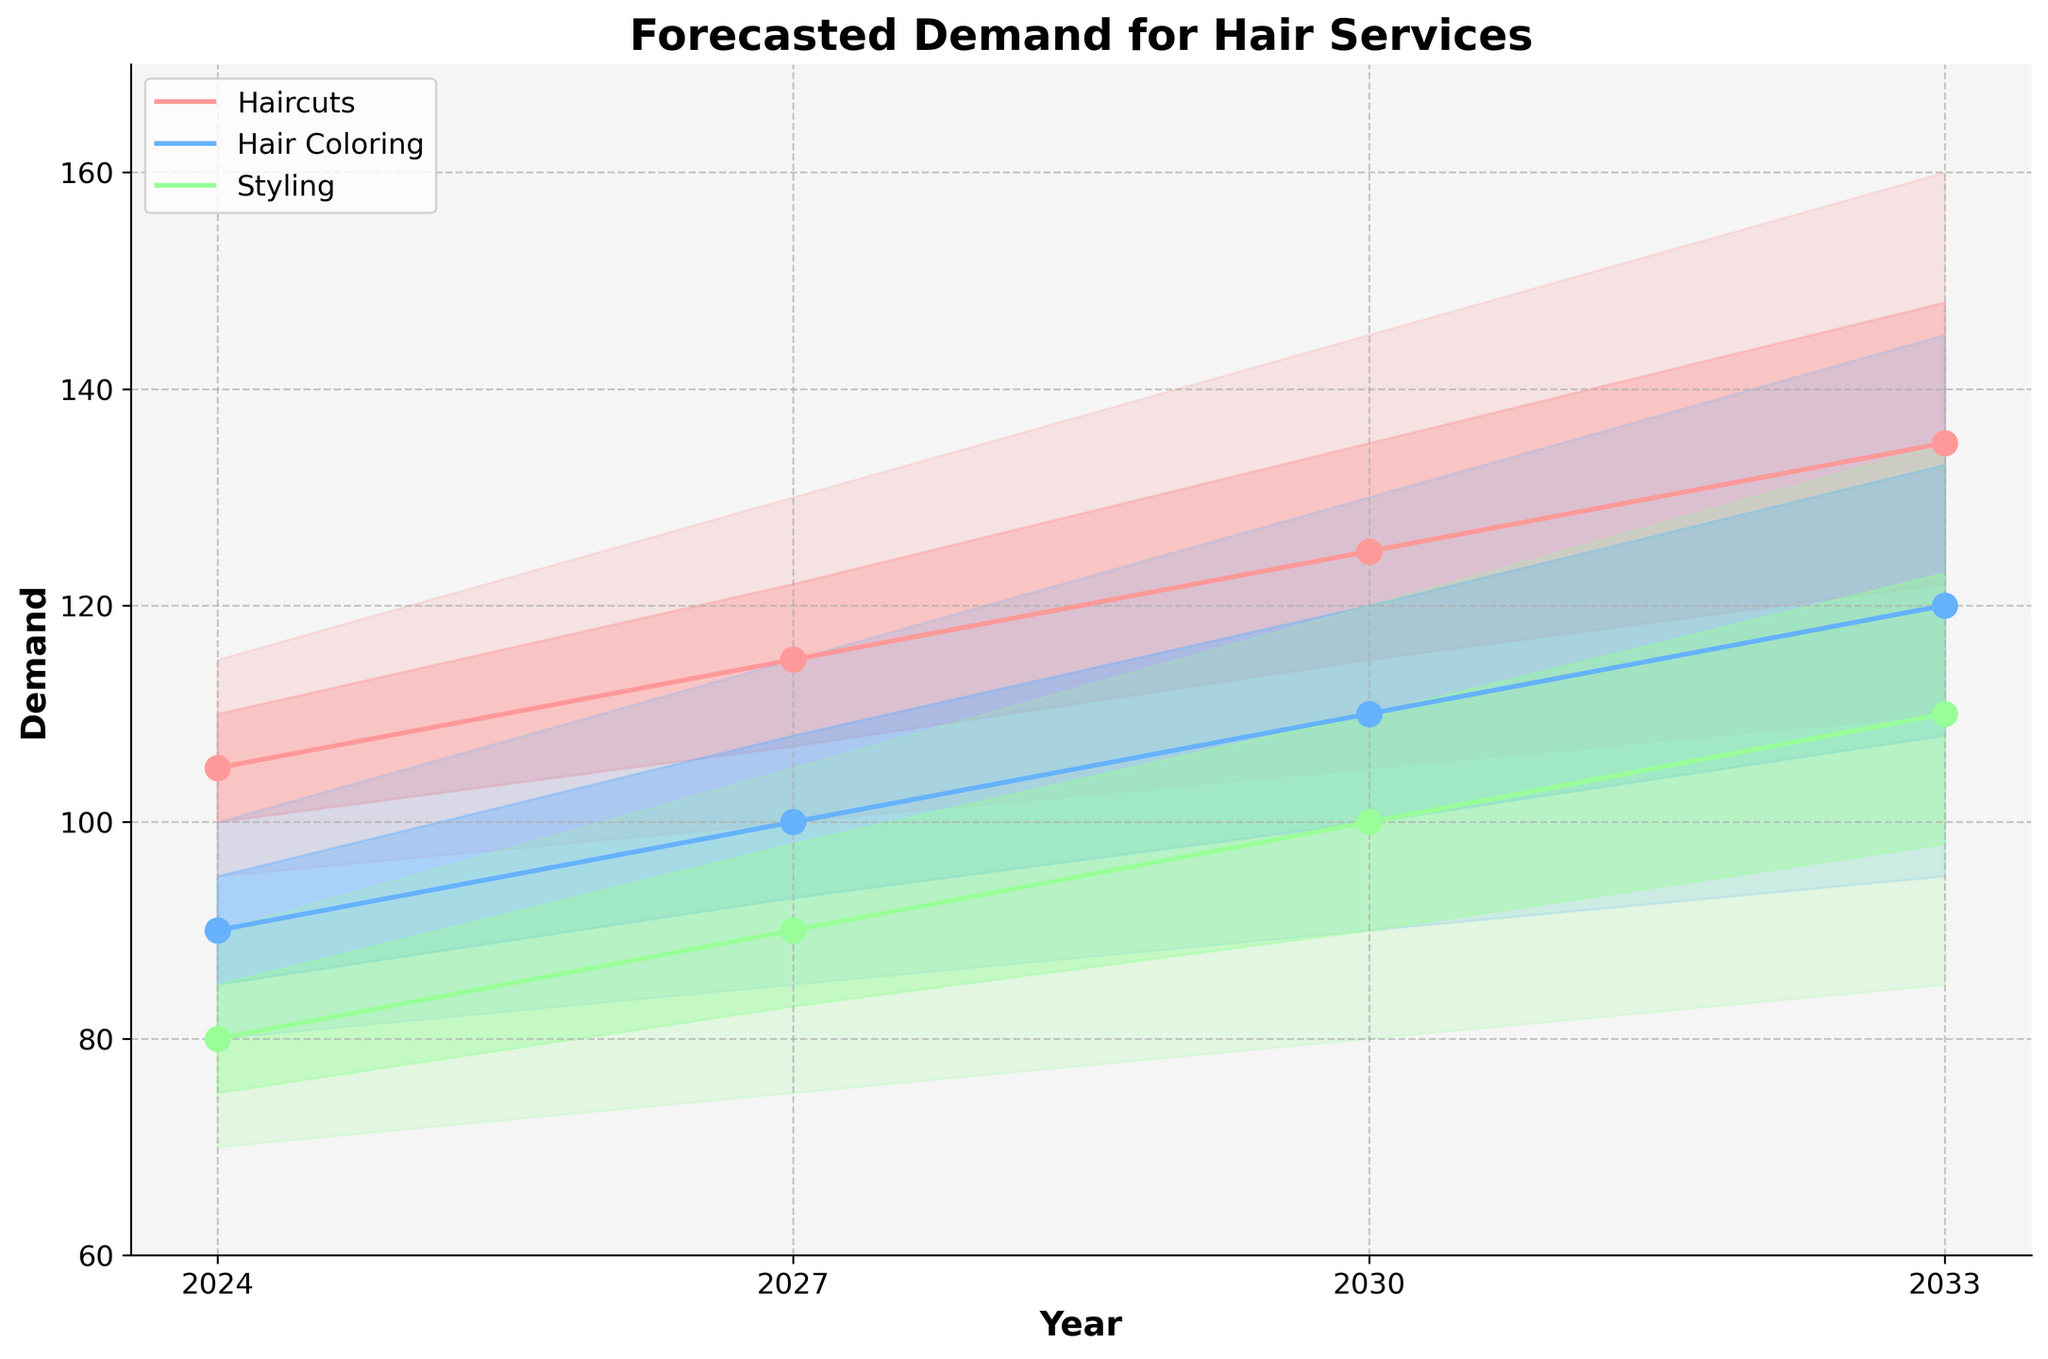What is the title of the figure? The title is located at the top of the figure and is designed to describe the subject of the chart clearly.
Answer: Forecasted Demand for Hair Services How many different types of hair services are forecasted in the figure? Observing the legend and different colors in the chart will show how many distinct services are depicted.
Answer: Three In what year is the median forecasted demand for haircuts the highest? The "Mid" line for haircuts represents the median forecast. Look for the peak of this line along the timeline.
Answer: 2033 What is the forecasted median demand for hair coloring in 2027? Locate the "Hair Coloring" service and find the median value for the year 2027.
Answer: 100 Which hair service shows the highest uncertainty range in 2033? The uncertainty range is depicted by the shaded regions. The highest range can be determined by comparing the height of the shaded areas for 2033 across all services.
Answer: Haircuts How much is the mid-range forecast for styling expected to increase from 2024 to 2030? Find the median value for styling in 2024 and 2030, then calculate the difference.
Answer: 20 Which service is predicted to have the least demand in 2024? Compare the lowest median values among the three services for 2024.
Answer: Styling By how much does the upper bound of the forecasted demand for haircuts increase from 2027 to 2033? The "High" value for 2027 and 2033 should be compared, and the difference calculated.
Answer: 30 What is the forecasted median demand for all services in 2027? Find the median values (Mid) for all services in 2027 and sum them up.
Answer: 305 Which service shows the smallest percentage increase in its median forecast from 2024 to 2030? Calculate the percentage increase for each service by comparing their median values in 2024 and 2030, then determine the smallest one.
Answer: Hair Coloring 